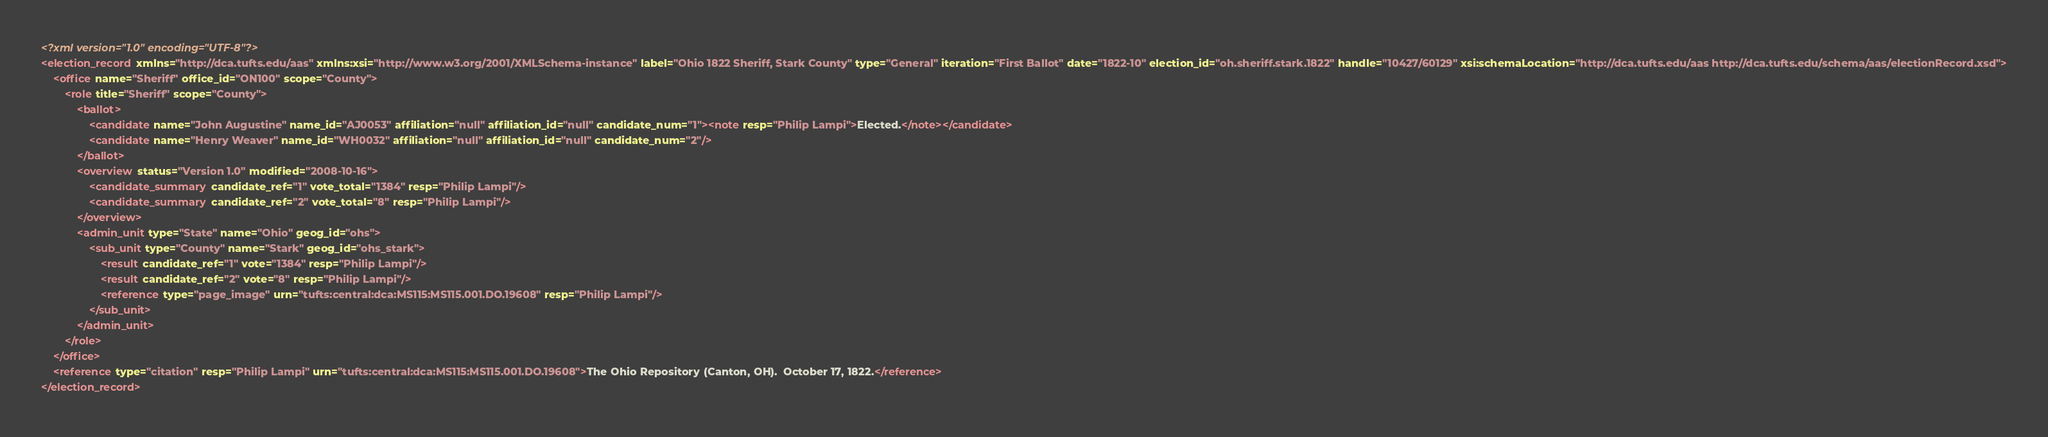Convert code to text. <code><loc_0><loc_0><loc_500><loc_500><_XML_><?xml version="1.0" encoding="UTF-8"?>
<election_record xmlns="http://dca.tufts.edu/aas" xmlns:xsi="http://www.w3.org/2001/XMLSchema-instance" label="Ohio 1822 Sheriff, Stark County" type="General" iteration="First Ballot" date="1822-10" election_id="oh.sheriff.stark.1822" handle="10427/60129" xsi:schemaLocation="http://dca.tufts.edu/aas http://dca.tufts.edu/schema/aas/electionRecord.xsd">
    <office name="Sheriff" office_id="ON100" scope="County">
        <role title="Sheriff" scope="County">
            <ballot>
                <candidate name="John Augustine" name_id="AJ0053" affiliation="null" affiliation_id="null" candidate_num="1"><note resp="Philip Lampi">Elected.</note></candidate>
                <candidate name="Henry Weaver" name_id="WH0032" affiliation="null" affiliation_id="null" candidate_num="2"/>
            </ballot>
            <overview status="Version 1.0" modified="2008-10-16">
                <candidate_summary candidate_ref="1" vote_total="1384" resp="Philip Lampi"/>
                <candidate_summary candidate_ref="2" vote_total="8" resp="Philip Lampi"/>
            </overview>
            <admin_unit type="State" name="Ohio" geog_id="ohs">
                <sub_unit type="County" name="Stark" geog_id="ohs_stark">
                    <result candidate_ref="1" vote="1384" resp="Philip Lampi"/>
                    <result candidate_ref="2" vote="8" resp="Philip Lampi"/>
                    <reference type="page_image" urn="tufts:central:dca:MS115:MS115.001.DO.19608" resp="Philip Lampi"/>
                </sub_unit>
            </admin_unit>
        </role>
    </office>
    <reference type="citation" resp="Philip Lampi" urn="tufts:central:dca:MS115:MS115.001.DO.19608">The Ohio Repository (Canton, OH).  October 17, 1822.</reference>
</election_record>
</code> 